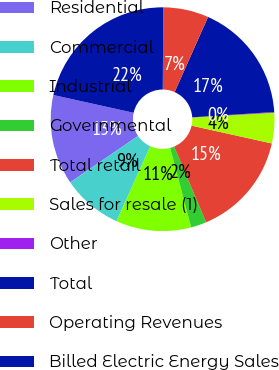Convert chart. <chart><loc_0><loc_0><loc_500><loc_500><pie_chart><fcel>Residential<fcel>Commercial<fcel>Industrial<fcel>Governmental<fcel>Total retail<fcel>Sales for resale (1)<fcel>Other<fcel>Total<fcel>Operating Revenues<fcel>Billed Electric Energy Sales<nl><fcel>13.01%<fcel>8.71%<fcel>10.86%<fcel>2.25%<fcel>15.17%<fcel>4.4%<fcel>0.1%<fcel>17.32%<fcel>6.56%<fcel>21.63%<nl></chart> 